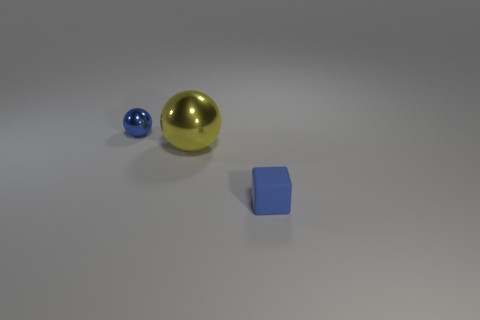Add 2 big yellow shiny balls. How many objects exist? 5 Subtract all blocks. How many objects are left? 2 Add 3 blue rubber blocks. How many blue rubber blocks are left? 4 Add 1 tiny blue metal objects. How many tiny blue metal objects exist? 2 Subtract 0 brown cylinders. How many objects are left? 3 Subtract all blue spheres. Subtract all brown cylinders. How many objects are left? 2 